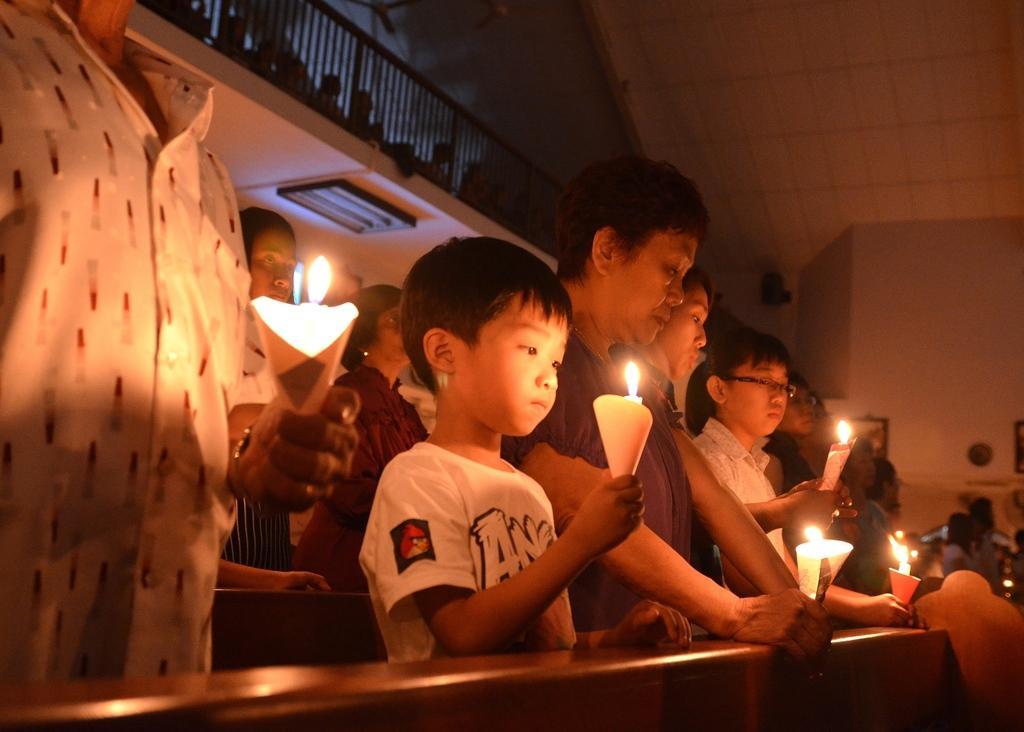Please provide a concise description of this image. In the image there are few people standing and holding the candles in their hands. At the top of the image there is a railing. In the background there is a wall with frames and few other objects. 